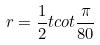Convert formula to latex. <formula><loc_0><loc_0><loc_500><loc_500>r = \frac { 1 } { 2 } t c o t \frac { \pi } { 8 0 }</formula> 